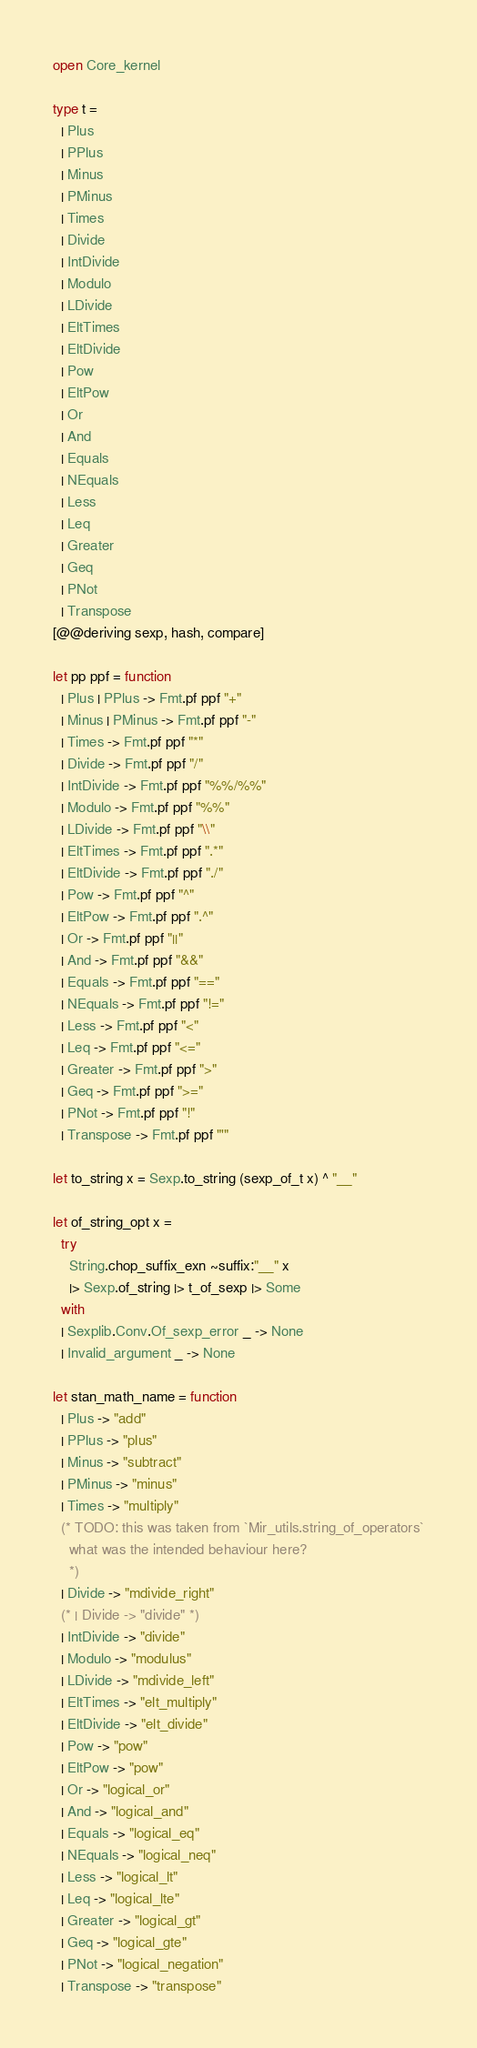Convert code to text. <code><loc_0><loc_0><loc_500><loc_500><_OCaml_>open Core_kernel

type t =
  | Plus
  | PPlus
  | Minus
  | PMinus
  | Times
  | Divide
  | IntDivide
  | Modulo
  | LDivide
  | EltTimes
  | EltDivide
  | Pow
  | EltPow
  | Or
  | And
  | Equals
  | NEquals
  | Less
  | Leq
  | Greater
  | Geq
  | PNot
  | Transpose
[@@deriving sexp, hash, compare]

let pp ppf = function
  | Plus | PPlus -> Fmt.pf ppf "+"
  | Minus | PMinus -> Fmt.pf ppf "-"
  | Times -> Fmt.pf ppf "*"
  | Divide -> Fmt.pf ppf "/"
  | IntDivide -> Fmt.pf ppf "%%/%%"
  | Modulo -> Fmt.pf ppf "%%"
  | LDivide -> Fmt.pf ppf "\\"
  | EltTimes -> Fmt.pf ppf ".*"
  | EltDivide -> Fmt.pf ppf "./"
  | Pow -> Fmt.pf ppf "^"
  | EltPow -> Fmt.pf ppf ".^"
  | Or -> Fmt.pf ppf "||"
  | And -> Fmt.pf ppf "&&"
  | Equals -> Fmt.pf ppf "=="
  | NEquals -> Fmt.pf ppf "!="
  | Less -> Fmt.pf ppf "<"
  | Leq -> Fmt.pf ppf "<="
  | Greater -> Fmt.pf ppf ">"
  | Geq -> Fmt.pf ppf ">="
  | PNot -> Fmt.pf ppf "!"
  | Transpose -> Fmt.pf ppf "'"

let to_string x = Sexp.to_string (sexp_of_t x) ^ "__"

let of_string_opt x =
  try
    String.chop_suffix_exn ~suffix:"__" x
    |> Sexp.of_string |> t_of_sexp |> Some
  with
  | Sexplib.Conv.Of_sexp_error _ -> None
  | Invalid_argument _ -> None

let stan_math_name = function
  | Plus -> "add"
  | PPlus -> "plus"
  | Minus -> "subtract"
  | PMinus -> "minus"
  | Times -> "multiply"
  (* TODO: this was taken from `Mir_utils.string_of_operators`
    what was the intended behaviour here?
    *)
  | Divide -> "mdivide_right"
  (* | Divide -> "divide" *)
  | IntDivide -> "divide"
  | Modulo -> "modulus"
  | LDivide -> "mdivide_left"
  | EltTimes -> "elt_multiply"
  | EltDivide -> "elt_divide"
  | Pow -> "pow"
  | EltPow -> "pow"
  | Or -> "logical_or"
  | And -> "logical_and"
  | Equals -> "logical_eq"
  | NEquals -> "logical_neq"
  | Less -> "logical_lt"
  | Leq -> "logical_lte"
  | Greater -> "logical_gt"
  | Geq -> "logical_gte"
  | PNot -> "logical_negation"
  | Transpose -> "transpose"
</code> 